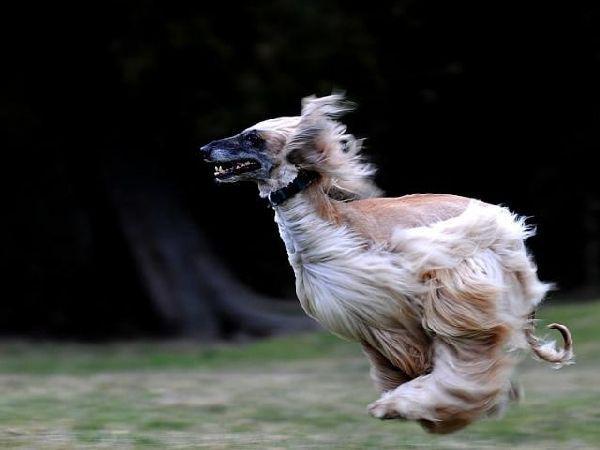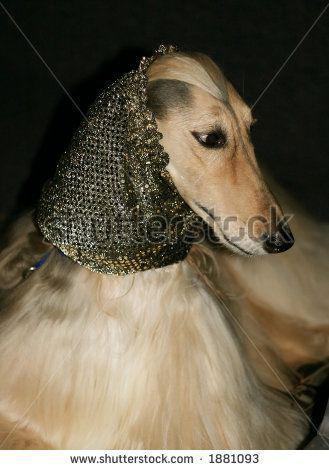The first image is the image on the left, the second image is the image on the right. Given the left and right images, does the statement "A sitting dog in one image is wearing an ornate head covering that extends down its neck." hold true? Answer yes or no. Yes. 